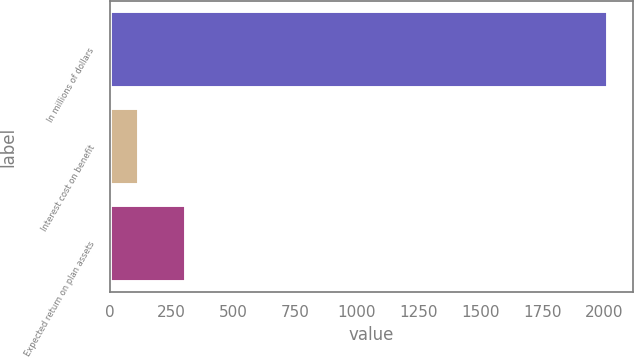Convert chart to OTSL. <chart><loc_0><loc_0><loc_500><loc_500><bar_chart><fcel>In millions of dollars<fcel>Interest cost on benefit<fcel>Expected return on plan assets<nl><fcel>2014<fcel>120<fcel>309.4<nl></chart> 